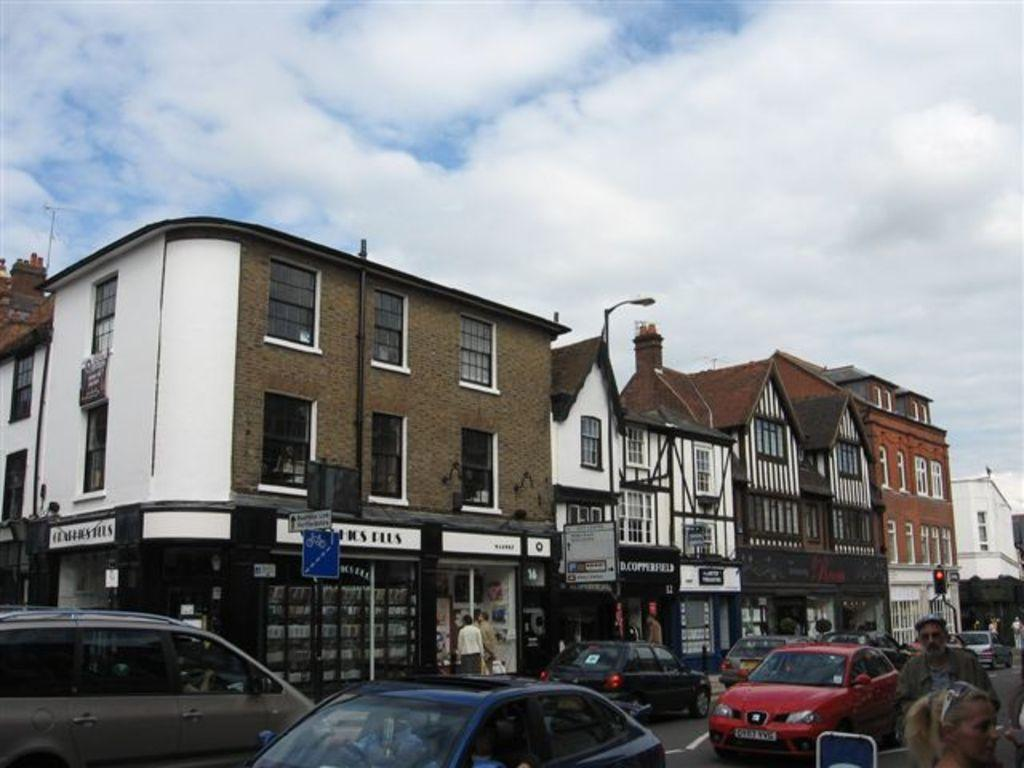What type of structure is visible in the image? There is a building in the image. What can be seen on the road near the building? There are cars parked on the road in the image. What type of connection can be seen between the building and the cars in the image? There is no specific connection between the building and the cars in the image; they are simply located near each other. 